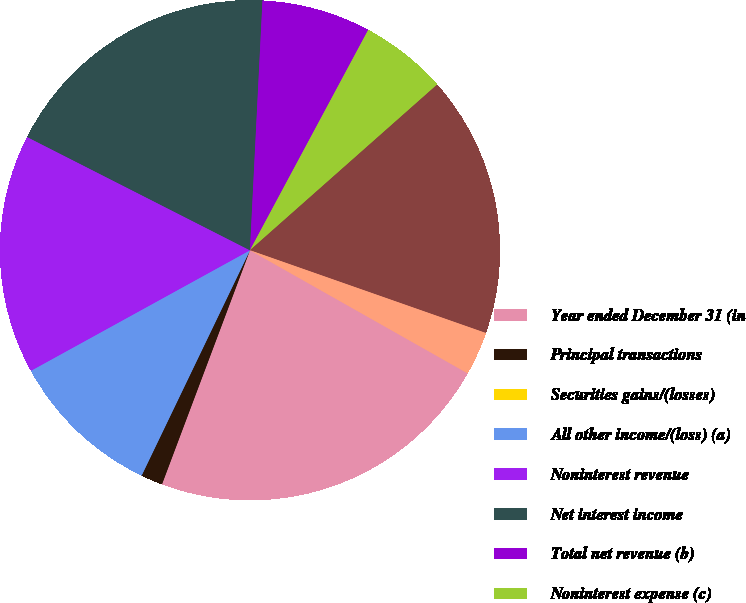Convert chart. <chart><loc_0><loc_0><loc_500><loc_500><pie_chart><fcel>Year ended December 31 (in<fcel>Principal transactions<fcel>Securities gains/(losses)<fcel>All other income/(loss) (a)<fcel>Noninterest revenue<fcel>Net interest income<fcel>Total net revenue (b)<fcel>Noninterest expense (c)<fcel>Income/(loss) before income<fcel>Income tax expense/(benefit)<nl><fcel>22.53%<fcel>1.41%<fcel>0.0%<fcel>9.86%<fcel>15.49%<fcel>18.31%<fcel>7.04%<fcel>5.63%<fcel>16.9%<fcel>2.82%<nl></chart> 